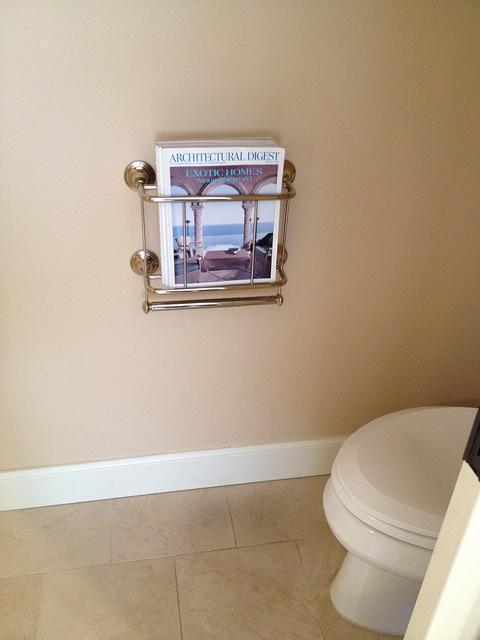How many magazines are in the rack?
Give a very brief answer. 1. How many items are on the wall?
Give a very brief answer. 1. 